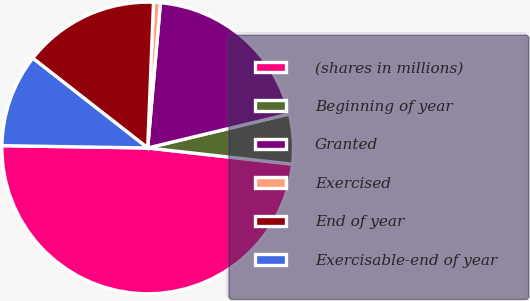<chart> <loc_0><loc_0><loc_500><loc_500><pie_chart><fcel>(shares in millions)<fcel>Beginning of year<fcel>Granted<fcel>Exercised<fcel>End of year<fcel>Exercisable-end of year<nl><fcel>48.48%<fcel>5.53%<fcel>19.85%<fcel>0.76%<fcel>15.08%<fcel>10.3%<nl></chart> 